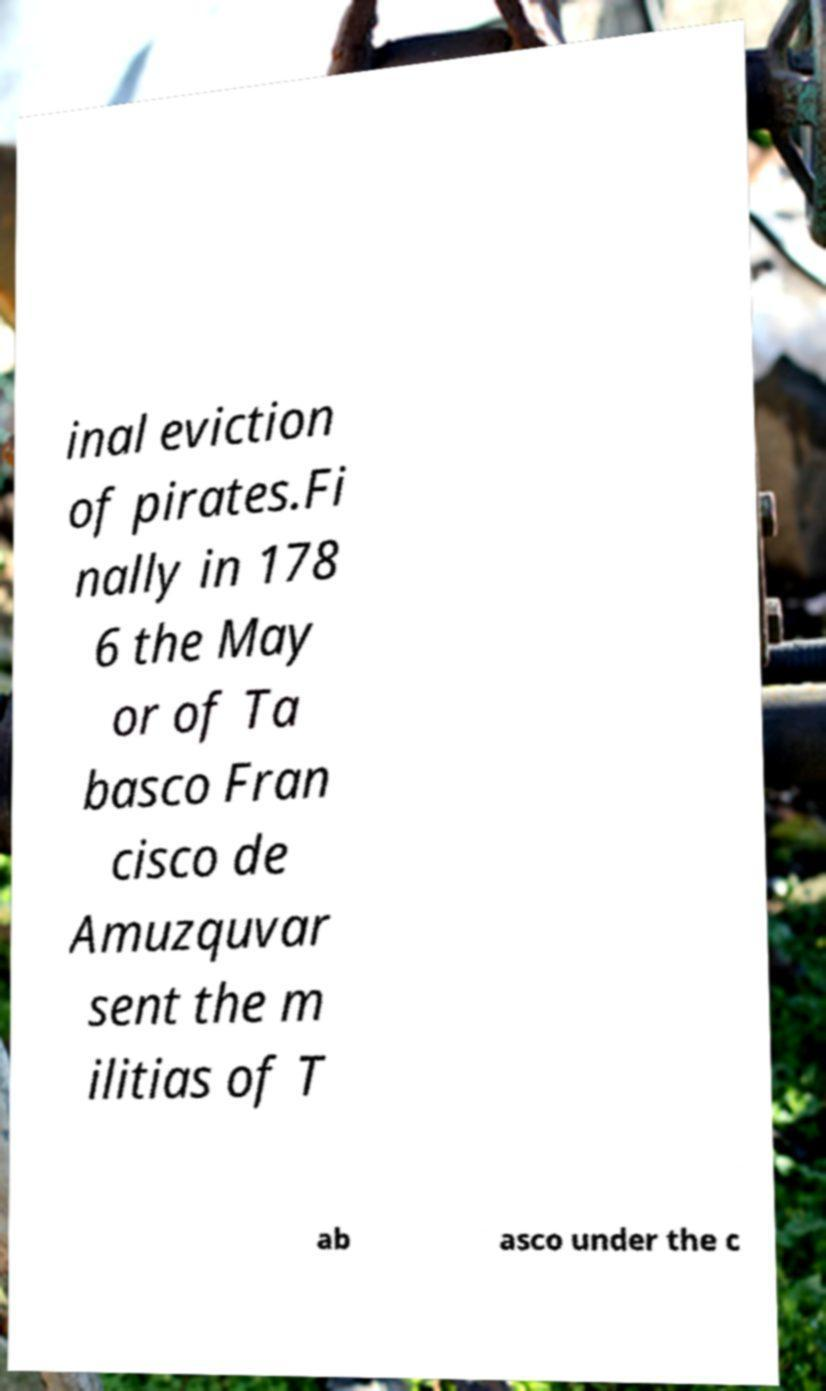Can you accurately transcribe the text from the provided image for me? inal eviction of pirates.Fi nally in 178 6 the May or of Ta basco Fran cisco de Amuzquvar sent the m ilitias of T ab asco under the c 